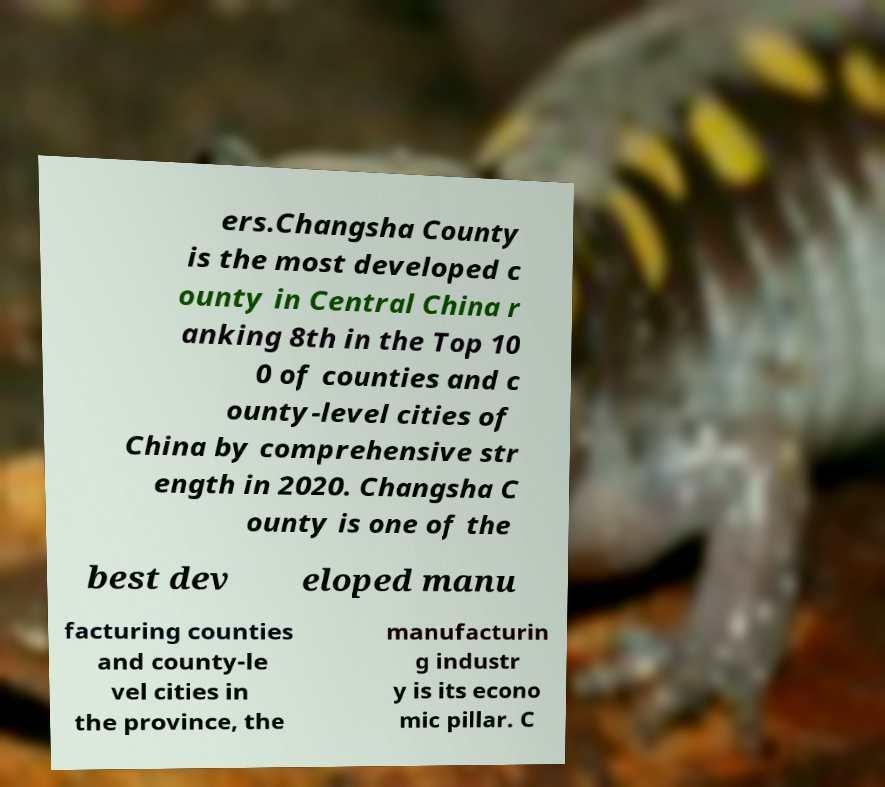Could you assist in decoding the text presented in this image and type it out clearly? ers.Changsha County is the most developed c ounty in Central China r anking 8th in the Top 10 0 of counties and c ounty-level cities of China by comprehensive str ength in 2020. Changsha C ounty is one of the best dev eloped manu facturing counties and county-le vel cities in the province, the manufacturin g industr y is its econo mic pillar. C 